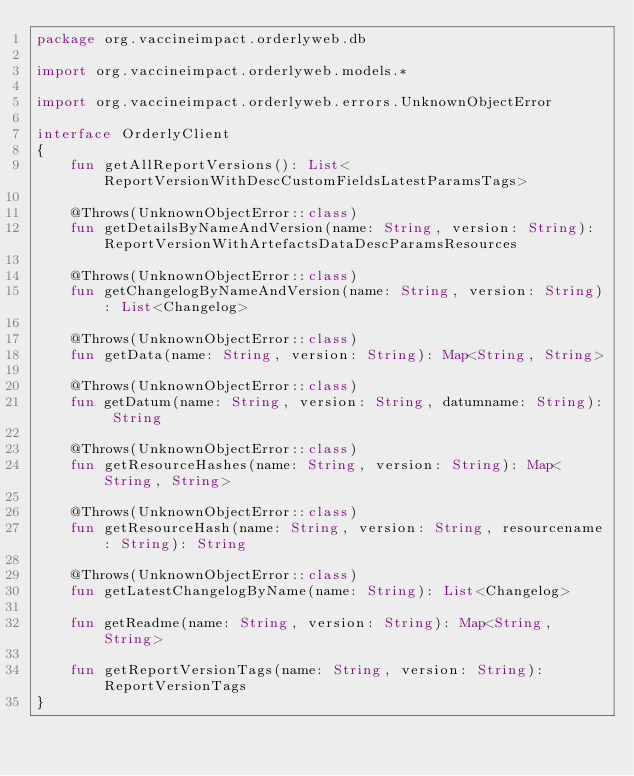<code> <loc_0><loc_0><loc_500><loc_500><_Kotlin_>package org.vaccineimpact.orderlyweb.db

import org.vaccineimpact.orderlyweb.models.*

import org.vaccineimpact.orderlyweb.errors.UnknownObjectError

interface OrderlyClient
{
    fun getAllReportVersions(): List<ReportVersionWithDescCustomFieldsLatestParamsTags>

    @Throws(UnknownObjectError::class)
    fun getDetailsByNameAndVersion(name: String, version: String): ReportVersionWithArtefactsDataDescParamsResources

    @Throws(UnknownObjectError::class)
    fun getChangelogByNameAndVersion(name: String, version: String): List<Changelog>

    @Throws(UnknownObjectError::class)
    fun getData(name: String, version: String): Map<String, String>

    @Throws(UnknownObjectError::class)
    fun getDatum(name: String, version: String, datumname: String): String

    @Throws(UnknownObjectError::class)
    fun getResourceHashes(name: String, version: String): Map<String, String>

    @Throws(UnknownObjectError::class)
    fun getResourceHash(name: String, version: String, resourcename: String): String

    @Throws(UnknownObjectError::class)
    fun getLatestChangelogByName(name: String): List<Changelog>

    fun getReadme(name: String, version: String): Map<String, String>

    fun getReportVersionTags(name: String, version: String): ReportVersionTags
}</code> 